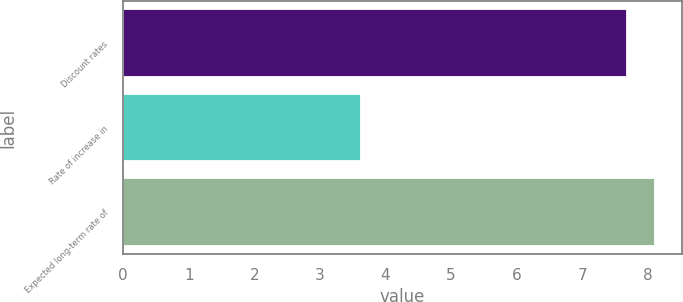<chart> <loc_0><loc_0><loc_500><loc_500><bar_chart><fcel>Discount rates<fcel>Rate of increase in<fcel>Expected long-term rate of<nl><fcel>7.68<fcel>3.62<fcel>8.11<nl></chart> 